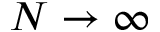Convert formula to latex. <formula><loc_0><loc_0><loc_500><loc_500>N \to \infty</formula> 